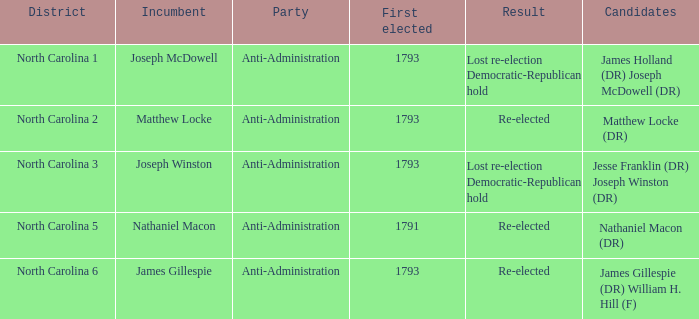Who was the candidate in 1791? Nathaniel Macon (DR). 